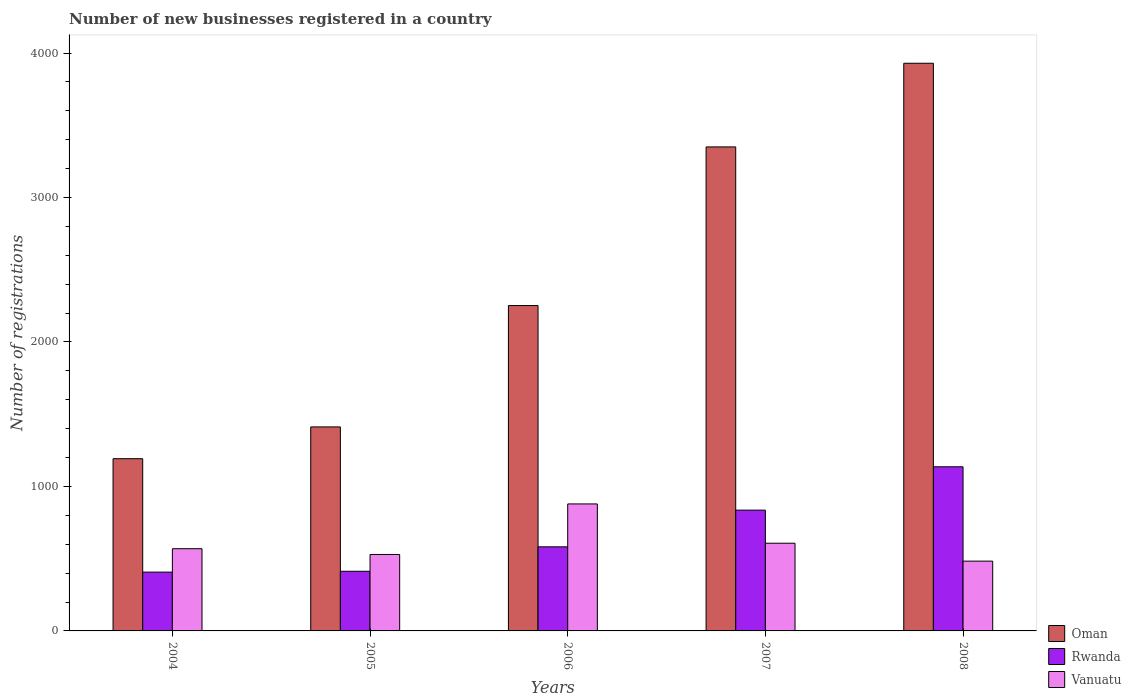Are the number of bars per tick equal to the number of legend labels?
Your answer should be compact. Yes. How many bars are there on the 4th tick from the left?
Offer a very short reply. 3. In how many cases, is the number of bars for a given year not equal to the number of legend labels?
Make the answer very short. 0. What is the number of new businesses registered in Rwanda in 2006?
Offer a terse response. 582. Across all years, what is the maximum number of new businesses registered in Vanuatu?
Give a very brief answer. 879. Across all years, what is the minimum number of new businesses registered in Oman?
Your response must be concise. 1192. In which year was the number of new businesses registered in Vanuatu maximum?
Your response must be concise. 2006. In which year was the number of new businesses registered in Rwanda minimum?
Ensure brevity in your answer.  2004. What is the total number of new businesses registered in Rwanda in the graph?
Your answer should be compact. 3374. What is the difference between the number of new businesses registered in Vanuatu in 2005 and that in 2006?
Your answer should be very brief. -350. What is the difference between the number of new businesses registered in Vanuatu in 2008 and the number of new businesses registered in Oman in 2004?
Give a very brief answer. -709. What is the average number of new businesses registered in Rwanda per year?
Your answer should be compact. 674.8. In the year 2006, what is the difference between the number of new businesses registered in Vanuatu and number of new businesses registered in Rwanda?
Give a very brief answer. 297. What is the ratio of the number of new businesses registered in Oman in 2005 to that in 2006?
Your answer should be compact. 0.63. Is the difference between the number of new businesses registered in Vanuatu in 2005 and 2007 greater than the difference between the number of new businesses registered in Rwanda in 2005 and 2007?
Keep it short and to the point. Yes. What is the difference between the highest and the second highest number of new businesses registered in Rwanda?
Provide a short and direct response. 300. What is the difference between the highest and the lowest number of new businesses registered in Rwanda?
Provide a succinct answer. 729. What does the 3rd bar from the left in 2005 represents?
Ensure brevity in your answer.  Vanuatu. What does the 3rd bar from the right in 2006 represents?
Your response must be concise. Oman. Is it the case that in every year, the sum of the number of new businesses registered in Rwanda and number of new businesses registered in Vanuatu is greater than the number of new businesses registered in Oman?
Ensure brevity in your answer.  No. How many bars are there?
Your response must be concise. 15. Are the values on the major ticks of Y-axis written in scientific E-notation?
Give a very brief answer. No. Does the graph contain any zero values?
Offer a very short reply. No. What is the title of the graph?
Offer a very short reply. Number of new businesses registered in a country. What is the label or title of the X-axis?
Offer a terse response. Years. What is the label or title of the Y-axis?
Your answer should be compact. Number of registrations. What is the Number of registrations in Oman in 2004?
Give a very brief answer. 1192. What is the Number of registrations of Rwanda in 2004?
Give a very brief answer. 407. What is the Number of registrations in Vanuatu in 2004?
Keep it short and to the point. 569. What is the Number of registrations of Oman in 2005?
Your response must be concise. 1412. What is the Number of registrations in Rwanda in 2005?
Offer a terse response. 413. What is the Number of registrations of Vanuatu in 2005?
Ensure brevity in your answer.  529. What is the Number of registrations in Oman in 2006?
Make the answer very short. 2252. What is the Number of registrations in Rwanda in 2006?
Your answer should be compact. 582. What is the Number of registrations of Vanuatu in 2006?
Make the answer very short. 879. What is the Number of registrations of Oman in 2007?
Keep it short and to the point. 3350. What is the Number of registrations in Rwanda in 2007?
Ensure brevity in your answer.  836. What is the Number of registrations in Vanuatu in 2007?
Offer a very short reply. 607. What is the Number of registrations in Oman in 2008?
Ensure brevity in your answer.  3929. What is the Number of registrations of Rwanda in 2008?
Your answer should be very brief. 1136. What is the Number of registrations in Vanuatu in 2008?
Ensure brevity in your answer.  483. Across all years, what is the maximum Number of registrations of Oman?
Your answer should be compact. 3929. Across all years, what is the maximum Number of registrations in Rwanda?
Provide a short and direct response. 1136. Across all years, what is the maximum Number of registrations of Vanuatu?
Ensure brevity in your answer.  879. Across all years, what is the minimum Number of registrations of Oman?
Give a very brief answer. 1192. Across all years, what is the minimum Number of registrations of Rwanda?
Ensure brevity in your answer.  407. Across all years, what is the minimum Number of registrations in Vanuatu?
Make the answer very short. 483. What is the total Number of registrations of Oman in the graph?
Offer a very short reply. 1.21e+04. What is the total Number of registrations of Rwanda in the graph?
Make the answer very short. 3374. What is the total Number of registrations in Vanuatu in the graph?
Your response must be concise. 3067. What is the difference between the Number of registrations in Oman in 2004 and that in 2005?
Your answer should be very brief. -220. What is the difference between the Number of registrations in Rwanda in 2004 and that in 2005?
Keep it short and to the point. -6. What is the difference between the Number of registrations of Vanuatu in 2004 and that in 2005?
Keep it short and to the point. 40. What is the difference between the Number of registrations of Oman in 2004 and that in 2006?
Keep it short and to the point. -1060. What is the difference between the Number of registrations in Rwanda in 2004 and that in 2006?
Offer a terse response. -175. What is the difference between the Number of registrations of Vanuatu in 2004 and that in 2006?
Offer a terse response. -310. What is the difference between the Number of registrations in Oman in 2004 and that in 2007?
Give a very brief answer. -2158. What is the difference between the Number of registrations of Rwanda in 2004 and that in 2007?
Your answer should be compact. -429. What is the difference between the Number of registrations in Vanuatu in 2004 and that in 2007?
Make the answer very short. -38. What is the difference between the Number of registrations of Oman in 2004 and that in 2008?
Offer a terse response. -2737. What is the difference between the Number of registrations of Rwanda in 2004 and that in 2008?
Offer a terse response. -729. What is the difference between the Number of registrations in Oman in 2005 and that in 2006?
Make the answer very short. -840. What is the difference between the Number of registrations of Rwanda in 2005 and that in 2006?
Keep it short and to the point. -169. What is the difference between the Number of registrations in Vanuatu in 2005 and that in 2006?
Make the answer very short. -350. What is the difference between the Number of registrations in Oman in 2005 and that in 2007?
Provide a succinct answer. -1938. What is the difference between the Number of registrations in Rwanda in 2005 and that in 2007?
Give a very brief answer. -423. What is the difference between the Number of registrations in Vanuatu in 2005 and that in 2007?
Make the answer very short. -78. What is the difference between the Number of registrations of Oman in 2005 and that in 2008?
Your answer should be very brief. -2517. What is the difference between the Number of registrations of Rwanda in 2005 and that in 2008?
Make the answer very short. -723. What is the difference between the Number of registrations of Oman in 2006 and that in 2007?
Give a very brief answer. -1098. What is the difference between the Number of registrations of Rwanda in 2006 and that in 2007?
Offer a very short reply. -254. What is the difference between the Number of registrations of Vanuatu in 2006 and that in 2007?
Your answer should be very brief. 272. What is the difference between the Number of registrations of Oman in 2006 and that in 2008?
Provide a succinct answer. -1677. What is the difference between the Number of registrations of Rwanda in 2006 and that in 2008?
Provide a succinct answer. -554. What is the difference between the Number of registrations of Vanuatu in 2006 and that in 2008?
Your answer should be very brief. 396. What is the difference between the Number of registrations in Oman in 2007 and that in 2008?
Ensure brevity in your answer.  -579. What is the difference between the Number of registrations in Rwanda in 2007 and that in 2008?
Ensure brevity in your answer.  -300. What is the difference between the Number of registrations in Vanuatu in 2007 and that in 2008?
Give a very brief answer. 124. What is the difference between the Number of registrations of Oman in 2004 and the Number of registrations of Rwanda in 2005?
Give a very brief answer. 779. What is the difference between the Number of registrations in Oman in 2004 and the Number of registrations in Vanuatu in 2005?
Offer a very short reply. 663. What is the difference between the Number of registrations in Rwanda in 2004 and the Number of registrations in Vanuatu in 2005?
Make the answer very short. -122. What is the difference between the Number of registrations of Oman in 2004 and the Number of registrations of Rwanda in 2006?
Provide a short and direct response. 610. What is the difference between the Number of registrations in Oman in 2004 and the Number of registrations in Vanuatu in 2006?
Keep it short and to the point. 313. What is the difference between the Number of registrations of Rwanda in 2004 and the Number of registrations of Vanuatu in 2006?
Your answer should be compact. -472. What is the difference between the Number of registrations in Oman in 2004 and the Number of registrations in Rwanda in 2007?
Ensure brevity in your answer.  356. What is the difference between the Number of registrations in Oman in 2004 and the Number of registrations in Vanuatu in 2007?
Your answer should be very brief. 585. What is the difference between the Number of registrations of Rwanda in 2004 and the Number of registrations of Vanuatu in 2007?
Make the answer very short. -200. What is the difference between the Number of registrations in Oman in 2004 and the Number of registrations in Rwanda in 2008?
Provide a short and direct response. 56. What is the difference between the Number of registrations of Oman in 2004 and the Number of registrations of Vanuatu in 2008?
Provide a short and direct response. 709. What is the difference between the Number of registrations in Rwanda in 2004 and the Number of registrations in Vanuatu in 2008?
Keep it short and to the point. -76. What is the difference between the Number of registrations in Oman in 2005 and the Number of registrations in Rwanda in 2006?
Your response must be concise. 830. What is the difference between the Number of registrations of Oman in 2005 and the Number of registrations of Vanuatu in 2006?
Make the answer very short. 533. What is the difference between the Number of registrations in Rwanda in 2005 and the Number of registrations in Vanuatu in 2006?
Your answer should be very brief. -466. What is the difference between the Number of registrations in Oman in 2005 and the Number of registrations in Rwanda in 2007?
Provide a succinct answer. 576. What is the difference between the Number of registrations of Oman in 2005 and the Number of registrations of Vanuatu in 2007?
Keep it short and to the point. 805. What is the difference between the Number of registrations of Rwanda in 2005 and the Number of registrations of Vanuatu in 2007?
Offer a very short reply. -194. What is the difference between the Number of registrations in Oman in 2005 and the Number of registrations in Rwanda in 2008?
Your answer should be very brief. 276. What is the difference between the Number of registrations of Oman in 2005 and the Number of registrations of Vanuatu in 2008?
Make the answer very short. 929. What is the difference between the Number of registrations of Rwanda in 2005 and the Number of registrations of Vanuatu in 2008?
Provide a succinct answer. -70. What is the difference between the Number of registrations in Oman in 2006 and the Number of registrations in Rwanda in 2007?
Your response must be concise. 1416. What is the difference between the Number of registrations in Oman in 2006 and the Number of registrations in Vanuatu in 2007?
Give a very brief answer. 1645. What is the difference between the Number of registrations of Rwanda in 2006 and the Number of registrations of Vanuatu in 2007?
Make the answer very short. -25. What is the difference between the Number of registrations in Oman in 2006 and the Number of registrations in Rwanda in 2008?
Ensure brevity in your answer.  1116. What is the difference between the Number of registrations of Oman in 2006 and the Number of registrations of Vanuatu in 2008?
Keep it short and to the point. 1769. What is the difference between the Number of registrations of Rwanda in 2006 and the Number of registrations of Vanuatu in 2008?
Your answer should be very brief. 99. What is the difference between the Number of registrations of Oman in 2007 and the Number of registrations of Rwanda in 2008?
Your answer should be very brief. 2214. What is the difference between the Number of registrations of Oman in 2007 and the Number of registrations of Vanuatu in 2008?
Offer a very short reply. 2867. What is the difference between the Number of registrations in Rwanda in 2007 and the Number of registrations in Vanuatu in 2008?
Ensure brevity in your answer.  353. What is the average Number of registrations in Oman per year?
Keep it short and to the point. 2427. What is the average Number of registrations in Rwanda per year?
Keep it short and to the point. 674.8. What is the average Number of registrations in Vanuatu per year?
Offer a terse response. 613.4. In the year 2004, what is the difference between the Number of registrations in Oman and Number of registrations in Rwanda?
Provide a short and direct response. 785. In the year 2004, what is the difference between the Number of registrations in Oman and Number of registrations in Vanuatu?
Provide a short and direct response. 623. In the year 2004, what is the difference between the Number of registrations in Rwanda and Number of registrations in Vanuatu?
Offer a terse response. -162. In the year 2005, what is the difference between the Number of registrations of Oman and Number of registrations of Rwanda?
Offer a terse response. 999. In the year 2005, what is the difference between the Number of registrations in Oman and Number of registrations in Vanuatu?
Offer a very short reply. 883. In the year 2005, what is the difference between the Number of registrations in Rwanda and Number of registrations in Vanuatu?
Ensure brevity in your answer.  -116. In the year 2006, what is the difference between the Number of registrations of Oman and Number of registrations of Rwanda?
Provide a short and direct response. 1670. In the year 2006, what is the difference between the Number of registrations in Oman and Number of registrations in Vanuatu?
Offer a terse response. 1373. In the year 2006, what is the difference between the Number of registrations of Rwanda and Number of registrations of Vanuatu?
Offer a very short reply. -297. In the year 2007, what is the difference between the Number of registrations in Oman and Number of registrations in Rwanda?
Your response must be concise. 2514. In the year 2007, what is the difference between the Number of registrations of Oman and Number of registrations of Vanuatu?
Your answer should be very brief. 2743. In the year 2007, what is the difference between the Number of registrations in Rwanda and Number of registrations in Vanuatu?
Give a very brief answer. 229. In the year 2008, what is the difference between the Number of registrations in Oman and Number of registrations in Rwanda?
Your answer should be very brief. 2793. In the year 2008, what is the difference between the Number of registrations in Oman and Number of registrations in Vanuatu?
Make the answer very short. 3446. In the year 2008, what is the difference between the Number of registrations in Rwanda and Number of registrations in Vanuatu?
Keep it short and to the point. 653. What is the ratio of the Number of registrations of Oman in 2004 to that in 2005?
Your answer should be compact. 0.84. What is the ratio of the Number of registrations of Rwanda in 2004 to that in 2005?
Your answer should be compact. 0.99. What is the ratio of the Number of registrations of Vanuatu in 2004 to that in 2005?
Your answer should be very brief. 1.08. What is the ratio of the Number of registrations of Oman in 2004 to that in 2006?
Offer a very short reply. 0.53. What is the ratio of the Number of registrations of Rwanda in 2004 to that in 2006?
Make the answer very short. 0.7. What is the ratio of the Number of registrations in Vanuatu in 2004 to that in 2006?
Provide a succinct answer. 0.65. What is the ratio of the Number of registrations in Oman in 2004 to that in 2007?
Offer a very short reply. 0.36. What is the ratio of the Number of registrations of Rwanda in 2004 to that in 2007?
Give a very brief answer. 0.49. What is the ratio of the Number of registrations in Vanuatu in 2004 to that in 2007?
Give a very brief answer. 0.94. What is the ratio of the Number of registrations in Oman in 2004 to that in 2008?
Your response must be concise. 0.3. What is the ratio of the Number of registrations of Rwanda in 2004 to that in 2008?
Ensure brevity in your answer.  0.36. What is the ratio of the Number of registrations in Vanuatu in 2004 to that in 2008?
Ensure brevity in your answer.  1.18. What is the ratio of the Number of registrations in Oman in 2005 to that in 2006?
Your response must be concise. 0.63. What is the ratio of the Number of registrations of Rwanda in 2005 to that in 2006?
Give a very brief answer. 0.71. What is the ratio of the Number of registrations of Vanuatu in 2005 to that in 2006?
Provide a succinct answer. 0.6. What is the ratio of the Number of registrations of Oman in 2005 to that in 2007?
Make the answer very short. 0.42. What is the ratio of the Number of registrations of Rwanda in 2005 to that in 2007?
Keep it short and to the point. 0.49. What is the ratio of the Number of registrations of Vanuatu in 2005 to that in 2007?
Your response must be concise. 0.87. What is the ratio of the Number of registrations of Oman in 2005 to that in 2008?
Ensure brevity in your answer.  0.36. What is the ratio of the Number of registrations of Rwanda in 2005 to that in 2008?
Provide a short and direct response. 0.36. What is the ratio of the Number of registrations in Vanuatu in 2005 to that in 2008?
Keep it short and to the point. 1.1. What is the ratio of the Number of registrations in Oman in 2006 to that in 2007?
Offer a very short reply. 0.67. What is the ratio of the Number of registrations of Rwanda in 2006 to that in 2007?
Ensure brevity in your answer.  0.7. What is the ratio of the Number of registrations of Vanuatu in 2006 to that in 2007?
Give a very brief answer. 1.45. What is the ratio of the Number of registrations of Oman in 2006 to that in 2008?
Offer a very short reply. 0.57. What is the ratio of the Number of registrations in Rwanda in 2006 to that in 2008?
Provide a succinct answer. 0.51. What is the ratio of the Number of registrations in Vanuatu in 2006 to that in 2008?
Make the answer very short. 1.82. What is the ratio of the Number of registrations in Oman in 2007 to that in 2008?
Ensure brevity in your answer.  0.85. What is the ratio of the Number of registrations of Rwanda in 2007 to that in 2008?
Offer a very short reply. 0.74. What is the ratio of the Number of registrations in Vanuatu in 2007 to that in 2008?
Ensure brevity in your answer.  1.26. What is the difference between the highest and the second highest Number of registrations in Oman?
Offer a terse response. 579. What is the difference between the highest and the second highest Number of registrations in Rwanda?
Your answer should be very brief. 300. What is the difference between the highest and the second highest Number of registrations of Vanuatu?
Ensure brevity in your answer.  272. What is the difference between the highest and the lowest Number of registrations of Oman?
Keep it short and to the point. 2737. What is the difference between the highest and the lowest Number of registrations of Rwanda?
Your answer should be very brief. 729. What is the difference between the highest and the lowest Number of registrations of Vanuatu?
Your answer should be compact. 396. 